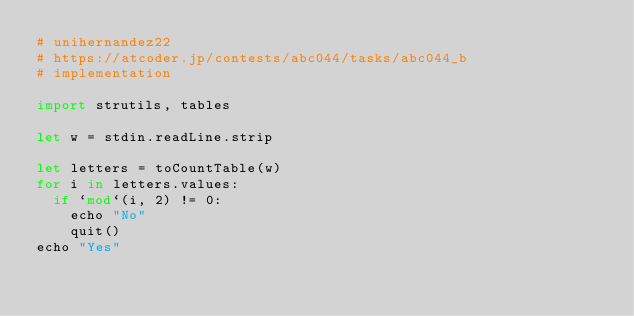<code> <loc_0><loc_0><loc_500><loc_500><_Nim_># unihernandez22
# https://atcoder.jp/contests/abc044/tasks/abc044_b
# implementation

import strutils, tables

let w = stdin.readLine.strip

let letters = toCountTable(w)
for i in letters.values:
  if `mod`(i, 2) != 0:
    echo "No"
    quit()
echo "Yes"
</code> 